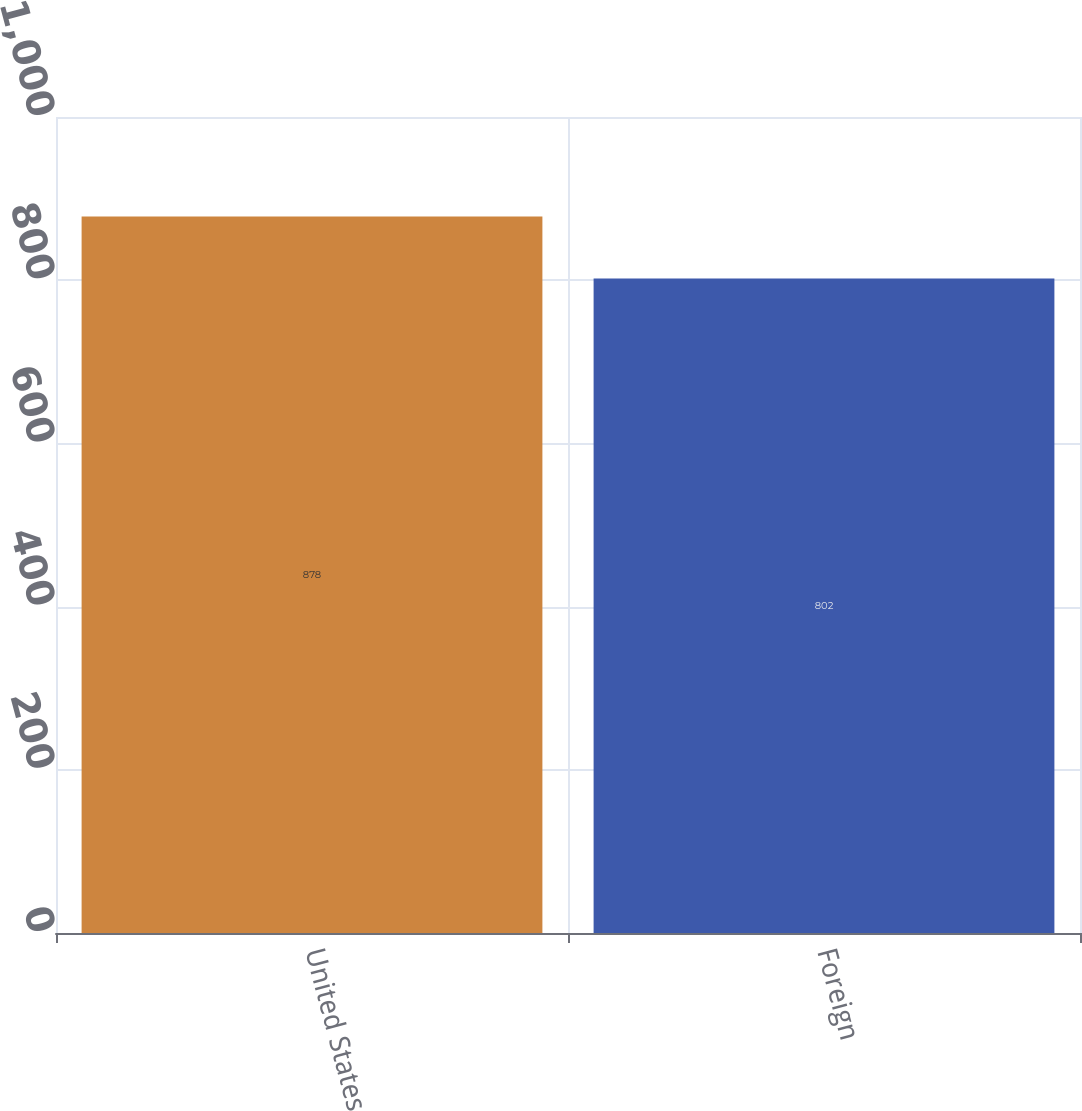Convert chart to OTSL. <chart><loc_0><loc_0><loc_500><loc_500><bar_chart><fcel>United States<fcel>Foreign<nl><fcel>878<fcel>802<nl></chart> 